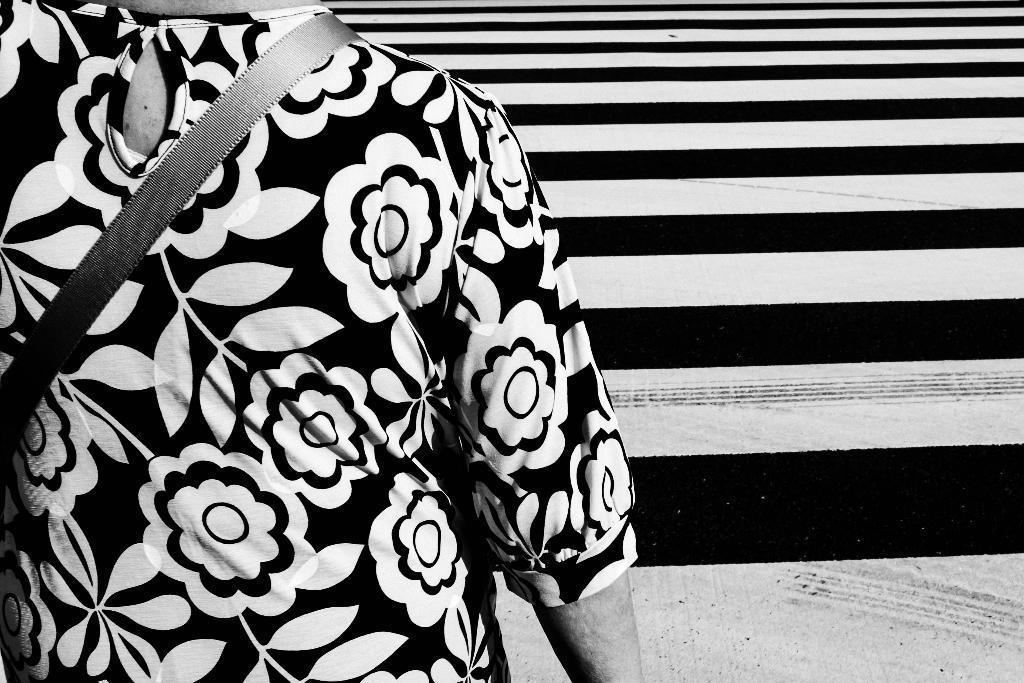Can you describe this image briefly? This is a black and white picture of a person standing near the stairs. 